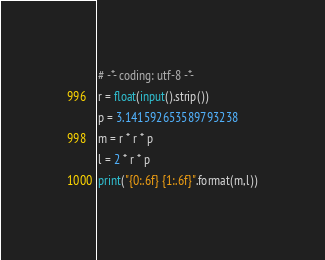Convert code to text. <code><loc_0><loc_0><loc_500><loc_500><_Python_># -*- coding: utf-8 -*-
r = float(input().strip())
p = 3.141592653589793238
m = r * r * p
l = 2 * r * p
print("{0:.6f} {1:.6f}".format(m,l))</code> 